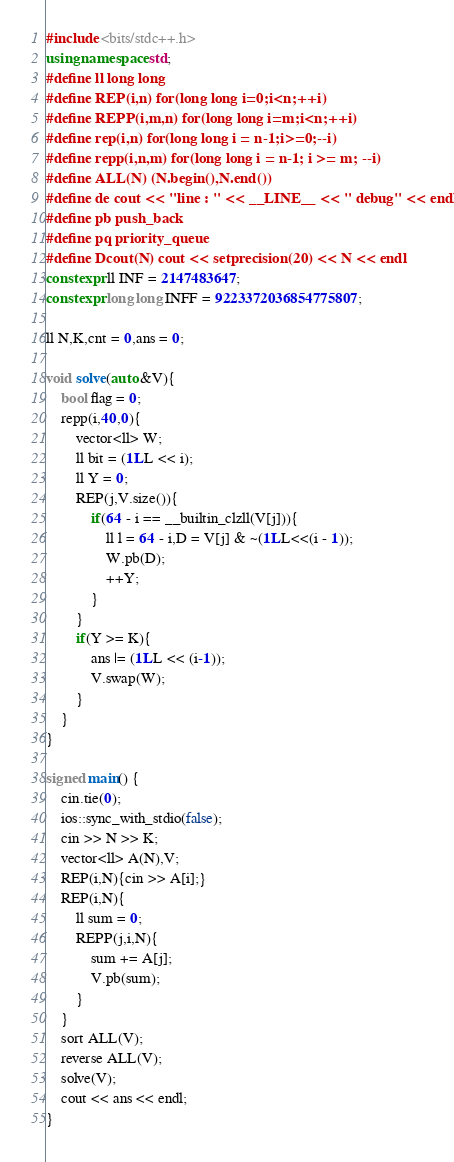Convert code to text. <code><loc_0><loc_0><loc_500><loc_500><_C++_>#include <bits/stdc++.h>
using namespace std;
#define ll long long
#define REP(i,n) for(long long i=0;i<n;++i)
#define REPP(i,m,n) for(long long i=m;i<n;++i)
#define rep(i,n) for(long long i = n-1;i>=0;--i)
#define repp(i,n,m) for(long long i = n-1; i >= m; --i)
#define ALL(N) (N.begin(),N.end())
#define de cout << "line : " << __LINE__ << " debug" << endl;
#define pb push_back
#define pq priority_queue
#define Dcout(N) cout << setprecision(20) << N << endl
constexpr ll INF = 2147483647;
constexpr long long INFF = 9223372036854775807;

ll N,K,cnt = 0,ans = 0;

void solve(auto &V){
    bool flag = 0;
    repp(i,40,0){
        vector<ll> W;
        ll bit = (1LL << i); 
        ll Y = 0;
        REP(j,V.size()){
            if(64 - i == __builtin_clzll(V[j])){
                ll l = 64 - i,D = V[j] & ~(1LL<<(i - 1));
                W.pb(D);
                ++Y;
            }
        }
        if(Y >= K){
            ans |= (1LL << (i-1));
            V.swap(W);
        }
    }
}

signed main() {
	cin.tie(0);
	ios::sync_with_stdio(false);
    cin >> N >> K;
    vector<ll> A(N),V;
    REP(i,N){cin >> A[i];}
    REP(i,N){
        ll sum = 0;
        REPP(j,i,N){
            sum += A[j];
            V.pb(sum);
        }
    }
    sort ALL(V);
    reverse ALL(V);
    solve(V);
    cout << ans << endl;
}</code> 